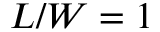<formula> <loc_0><loc_0><loc_500><loc_500>L / W = 1</formula> 